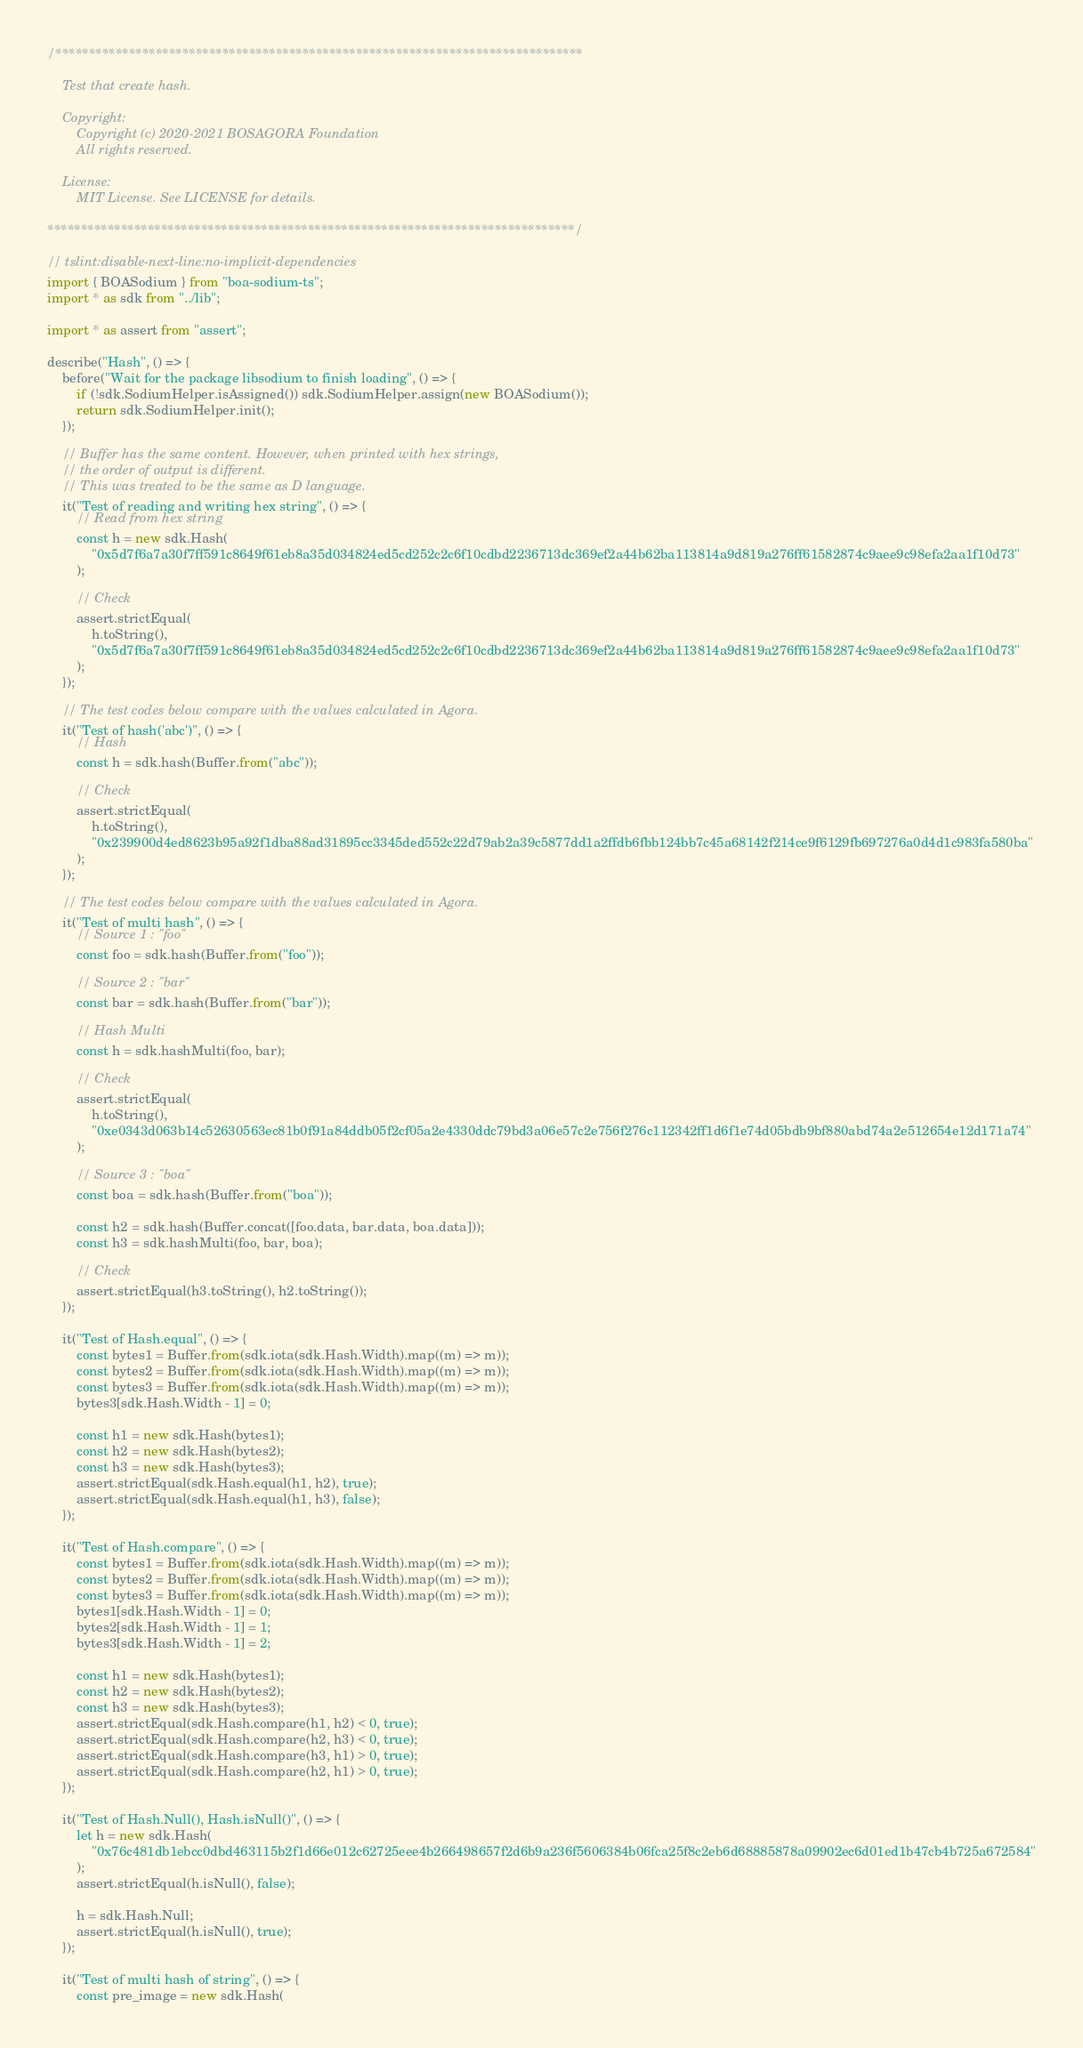Convert code to text. <code><loc_0><loc_0><loc_500><loc_500><_TypeScript_>/*******************************************************************************

    Test that create hash.

    Copyright:
        Copyright (c) 2020-2021 BOSAGORA Foundation
        All rights reserved.

    License:
        MIT License. See LICENSE for details.

*******************************************************************************/

// tslint:disable-next-line:no-implicit-dependencies
import { BOASodium } from "boa-sodium-ts";
import * as sdk from "../lib";

import * as assert from "assert";

describe("Hash", () => {
    before("Wait for the package libsodium to finish loading", () => {
        if (!sdk.SodiumHelper.isAssigned()) sdk.SodiumHelper.assign(new BOASodium());
        return sdk.SodiumHelper.init();
    });

    // Buffer has the same content. However, when printed with hex strings,
    // the order of output is different.
    // This was treated to be the same as D language.
    it("Test of reading and writing hex string", () => {
        // Read from hex string
        const h = new sdk.Hash(
            "0x5d7f6a7a30f7ff591c8649f61eb8a35d034824ed5cd252c2c6f10cdbd2236713dc369ef2a44b62ba113814a9d819a276ff61582874c9aee9c98efa2aa1f10d73"
        );

        // Check
        assert.strictEqual(
            h.toString(),
            "0x5d7f6a7a30f7ff591c8649f61eb8a35d034824ed5cd252c2c6f10cdbd2236713dc369ef2a44b62ba113814a9d819a276ff61582874c9aee9c98efa2aa1f10d73"
        );
    });

    // The test codes below compare with the values calculated in Agora.
    it("Test of hash('abc')", () => {
        // Hash
        const h = sdk.hash(Buffer.from("abc"));

        // Check
        assert.strictEqual(
            h.toString(),
            "0x239900d4ed8623b95a92f1dba88ad31895cc3345ded552c22d79ab2a39c5877dd1a2ffdb6fbb124bb7c45a68142f214ce9f6129fb697276a0d4d1c983fa580ba"
        );
    });

    // The test codes below compare with the values calculated in Agora.
    it("Test of multi hash", () => {
        // Source 1 : "foo"
        const foo = sdk.hash(Buffer.from("foo"));

        // Source 2 : "bar"
        const bar = sdk.hash(Buffer.from("bar"));

        // Hash Multi
        const h = sdk.hashMulti(foo, bar);

        // Check
        assert.strictEqual(
            h.toString(),
            "0xe0343d063b14c52630563ec81b0f91a84ddb05f2cf05a2e4330ddc79bd3a06e57c2e756f276c112342ff1d6f1e74d05bdb9bf880abd74a2e512654e12d171a74"
        );

        // Source 3 : "boa"
        const boa = sdk.hash(Buffer.from("boa"));

        const h2 = sdk.hash(Buffer.concat([foo.data, bar.data, boa.data]));
        const h3 = sdk.hashMulti(foo, bar, boa);

        // Check
        assert.strictEqual(h3.toString(), h2.toString());
    });

    it("Test of Hash.equal", () => {
        const bytes1 = Buffer.from(sdk.iota(sdk.Hash.Width).map((m) => m));
        const bytes2 = Buffer.from(sdk.iota(sdk.Hash.Width).map((m) => m));
        const bytes3 = Buffer.from(sdk.iota(sdk.Hash.Width).map((m) => m));
        bytes3[sdk.Hash.Width - 1] = 0;

        const h1 = new sdk.Hash(bytes1);
        const h2 = new sdk.Hash(bytes2);
        const h3 = new sdk.Hash(bytes3);
        assert.strictEqual(sdk.Hash.equal(h1, h2), true);
        assert.strictEqual(sdk.Hash.equal(h1, h3), false);
    });

    it("Test of Hash.compare", () => {
        const bytes1 = Buffer.from(sdk.iota(sdk.Hash.Width).map((m) => m));
        const bytes2 = Buffer.from(sdk.iota(sdk.Hash.Width).map((m) => m));
        const bytes3 = Buffer.from(sdk.iota(sdk.Hash.Width).map((m) => m));
        bytes1[sdk.Hash.Width - 1] = 0;
        bytes2[sdk.Hash.Width - 1] = 1;
        bytes3[sdk.Hash.Width - 1] = 2;

        const h1 = new sdk.Hash(bytes1);
        const h2 = new sdk.Hash(bytes2);
        const h3 = new sdk.Hash(bytes3);
        assert.strictEqual(sdk.Hash.compare(h1, h2) < 0, true);
        assert.strictEqual(sdk.Hash.compare(h2, h3) < 0, true);
        assert.strictEqual(sdk.Hash.compare(h3, h1) > 0, true);
        assert.strictEqual(sdk.Hash.compare(h2, h1) > 0, true);
    });

    it("Test of Hash.Null(), Hash.isNull()", () => {
        let h = new sdk.Hash(
            "0x76c481db1ebcc0dbd463115b2f1d66e012c62725eee4b266498657f2d6b9a236f5606384b06fca25f8c2eb6d68885878a09902ec6d01ed1b47cb4b725a672584"
        );
        assert.strictEqual(h.isNull(), false);

        h = sdk.Hash.Null;
        assert.strictEqual(h.isNull(), true);
    });

    it("Test of multi hash of string", () => {
        const pre_image = new sdk.Hash(</code> 